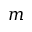<formula> <loc_0><loc_0><loc_500><loc_500>m</formula> 